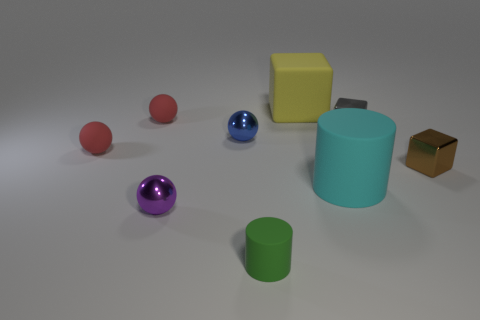Subtract 2 spheres. How many spheres are left? 2 Subtract all cyan spheres. Subtract all yellow cylinders. How many spheres are left? 4 Add 1 brown blocks. How many objects exist? 10 Subtract all spheres. How many objects are left? 5 Add 1 large rubber things. How many large rubber things exist? 3 Subtract 0 purple blocks. How many objects are left? 9 Subtract all tiny red matte things. Subtract all small gray cubes. How many objects are left? 6 Add 7 small metal spheres. How many small metal spheres are left? 9 